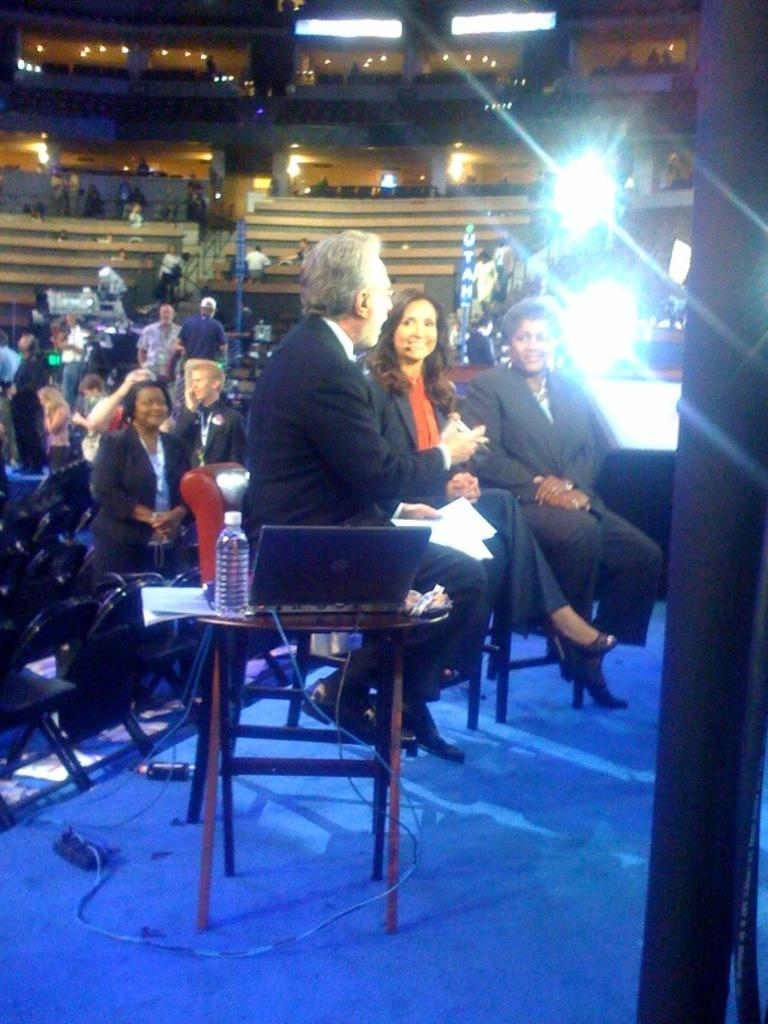How many people are in the image? There are three people in the image. What are the people sitting on? The people are sitting on chairs and a stool. What is on the stool? There is a laptop, papers, and a water bottle on the stool. What can be seen in the background of the image? There is a group of people, steps, and lights in the background of the image. What type of brush is being used by the person in the image? There is no brush visible in the image. What kind of breakfast is being prepared in the image? There is no breakfast preparation visible in the image. 